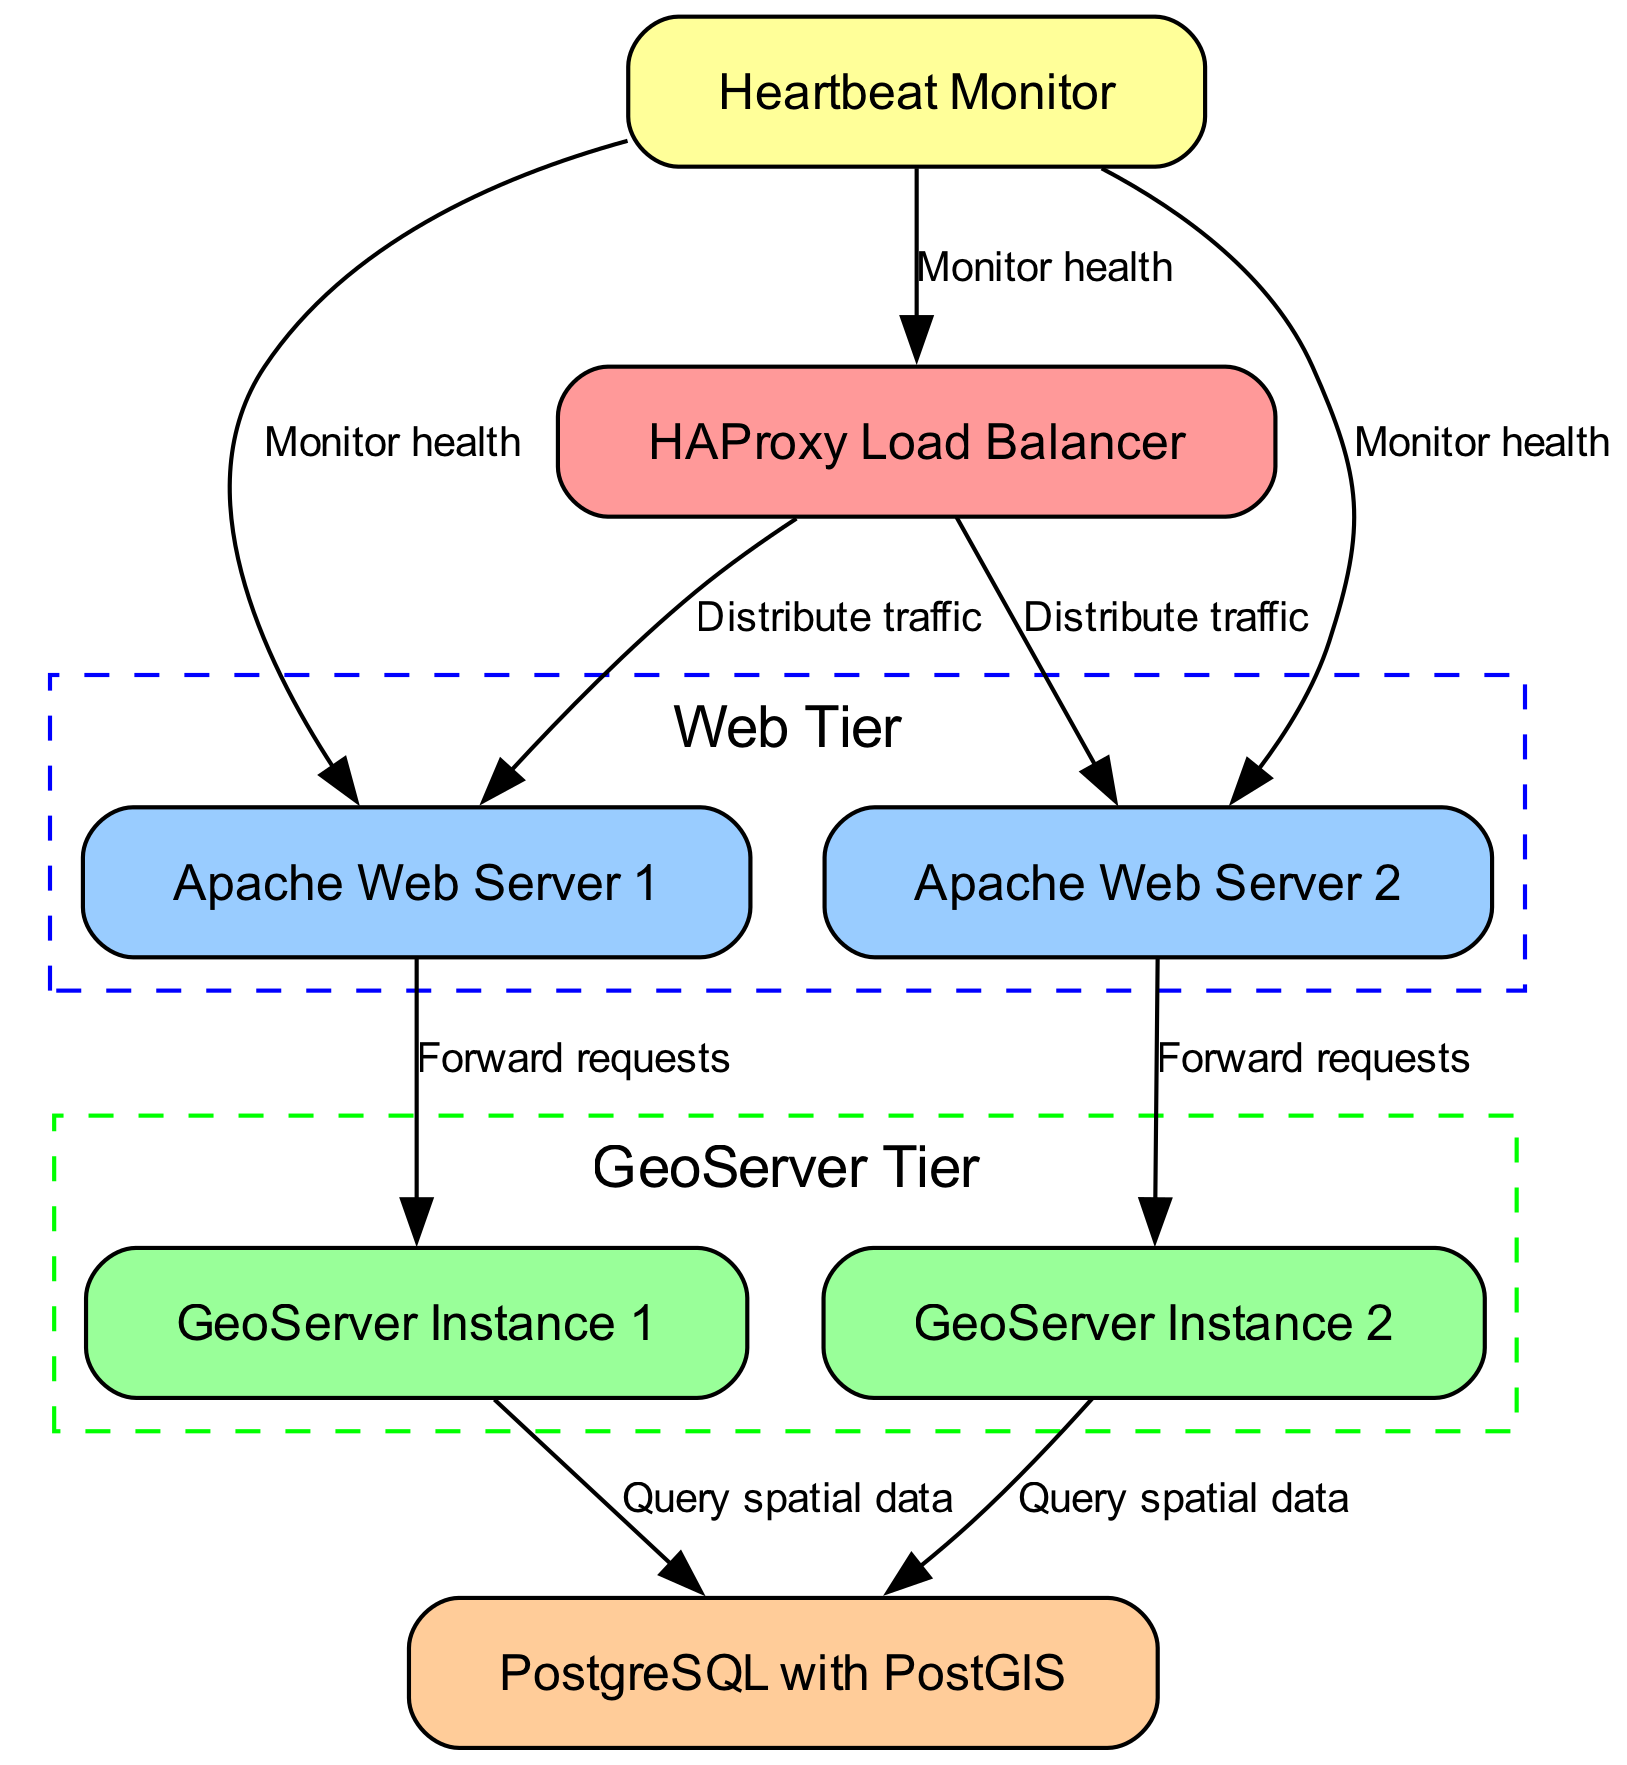What is the label of the node that distributes traffic? The node responsible for distributing traffic is labeled "HAProxy Load Balancer" according to the diagram.
Answer: HAProxy Load Balancer How many web servers are present in the diagram? The diagram shows two web servers: "Apache Web Server 1" and "Apache Web Server 2." By counting these nodes, we find that there are two.
Answer: 2 Which node does GeoServer Instance 1 query for spatial data? The arrow from "GeoServer Instance 1" points to "PostgreSQL with PostGIS," indicating that it queries this node for spatial data.
Answer: PostgreSQL with PostGIS What is the primary function of the Heartbeat Monitor? The Heartbeat Monitor checks the health of the nodes it connects to, ensuring they are operational and able to handle requests. This is shown by its connections to multiple nodes.
Answer: Monitor health What is the relationship between Apache Web Server 1 and GeoServer Instance 1? Apache Web Server 1 has a direct edge connecting it to GeoServer Instance 1 labeled "Forward requests," indicating it forwards incoming requests to this GeoServer instance.
Answer: Forward requests If Apache Web Server 2 fails, what will happen to the traffic? The Load Balancer will still manage traffic to Apache Web Server 1, maintaining service availability, as indicated by its ability to distribute traffic among the web servers.
Answer: HAProxy Load Balancer still distributes traffic How many health monitoring lines are drawn between the Heartbeat Monitor and other nodes? There are three lines drawn from the Heartbeat Monitor to "LoadBalancer," "WebServer1," and "WebServer2," indicating that it monitors their health.
Answer: 3 What does PostgreSQL with PostGIS provide to the GeoServer instances? PostgreSQL with PostGIS provides spatial data to the GeoServer instances as indicated by the edges labeled "Query spatial data."
Answer: Spatial data What ensures high availability in this setup? The combination of the Load Balancer distributing traffic and the Heartbeat Monitor checking node health ensures high availability in this geospatial web service architecture.
Answer: Load Balancer and Heartbeat Monitor 